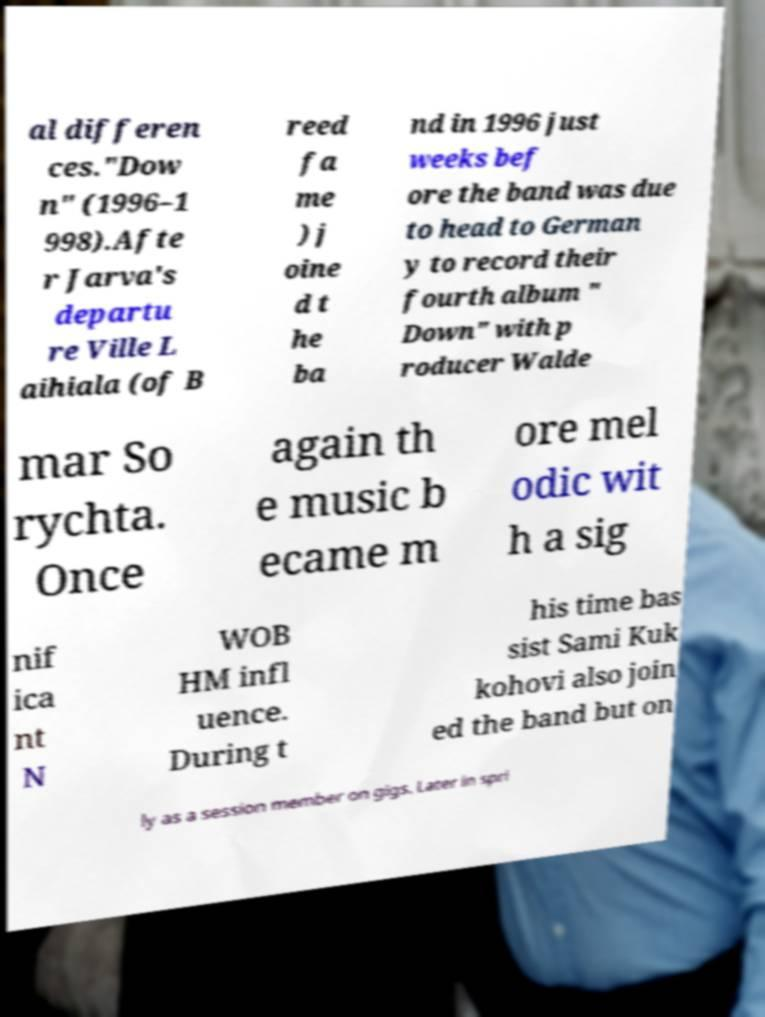There's text embedded in this image that I need extracted. Can you transcribe it verbatim? al differen ces."Dow n" (1996–1 998).Afte r Jarva's departu re Ville L aihiala (of B reed fa me ) j oine d t he ba nd in 1996 just weeks bef ore the band was due to head to German y to record their fourth album " Down" with p roducer Walde mar So rychta. Once again th e music b ecame m ore mel odic wit h a sig nif ica nt N WOB HM infl uence. During t his time bas sist Sami Kuk kohovi also join ed the band but on ly as a session member on gigs. Later in spri 